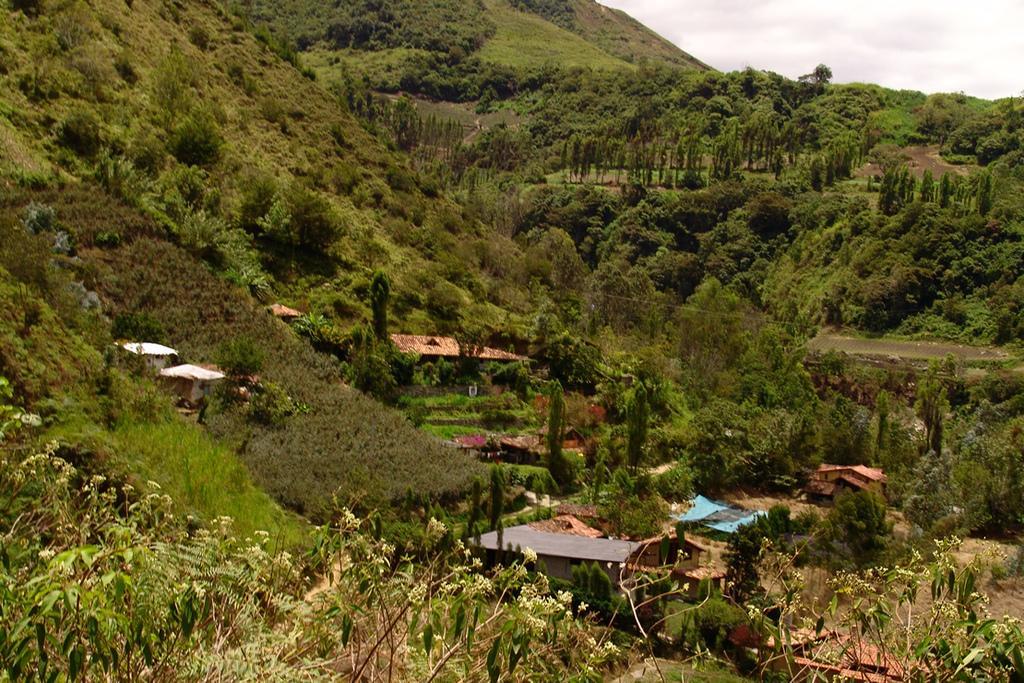Please provide a concise description of this image. In this image in the center there are some houses, at the bottom of the image there are some plants. And in the bottom there are some trees and mountains, at the top there is sky. 